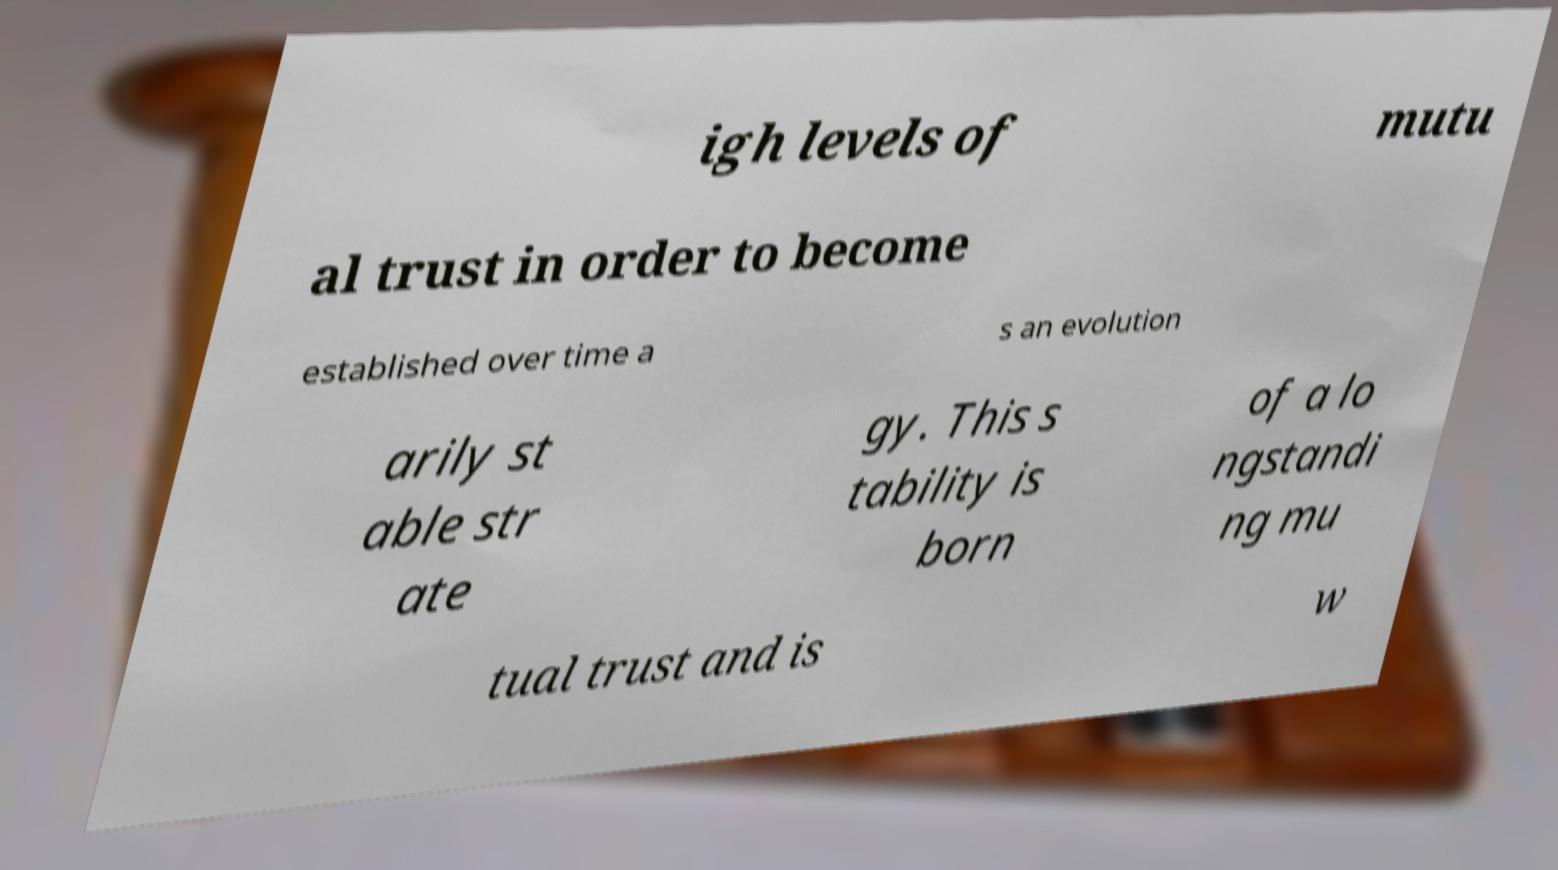Could you extract and type out the text from this image? igh levels of mutu al trust in order to become established over time a s an evolution arily st able str ate gy. This s tability is born of a lo ngstandi ng mu tual trust and is w 